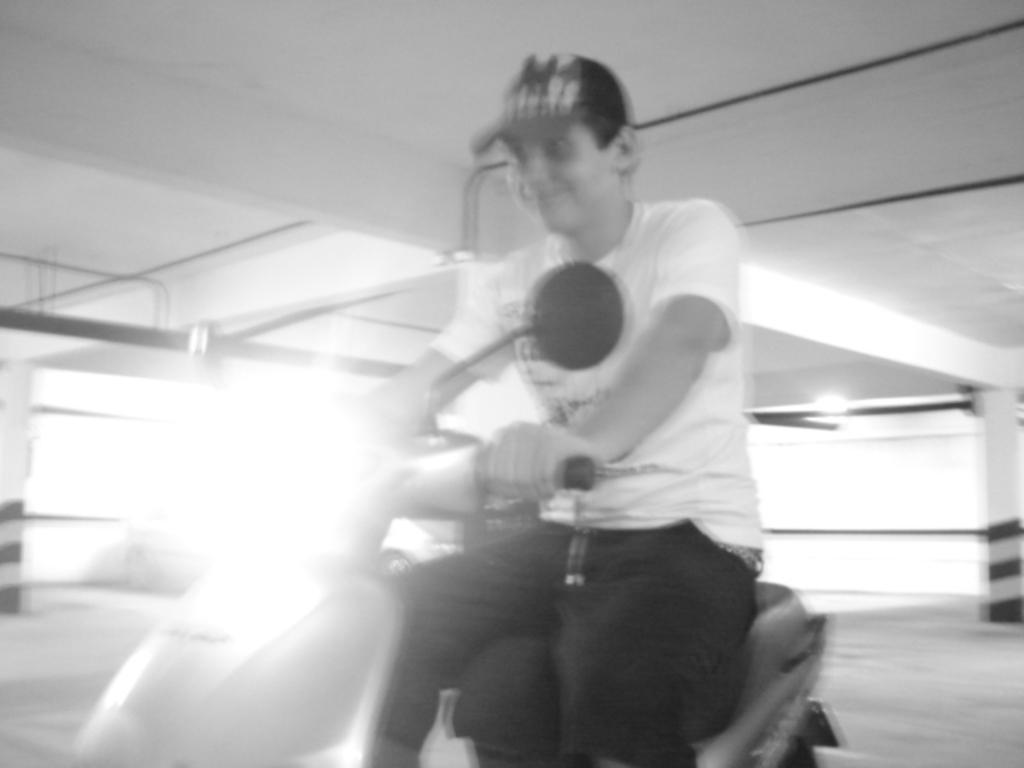Could you give a brief overview of what you see in this image? This picture seems to be clicked inside. In the foreground there is a person riding a bike. At the top we and see the roof. In the background we can see the wall, pillars and metal rods. 